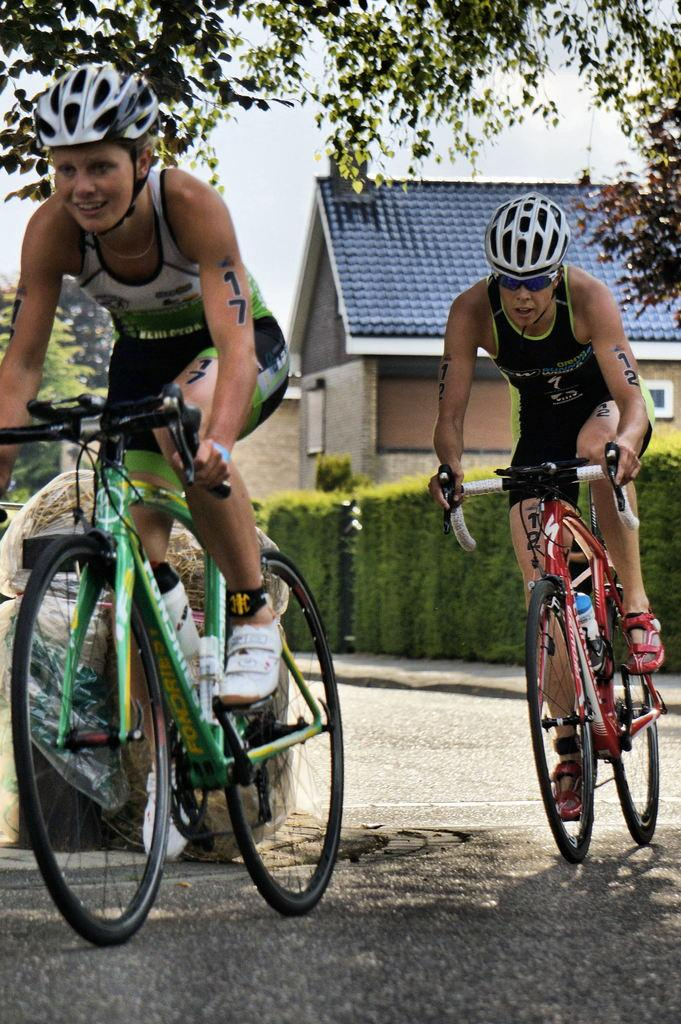What are the two people in the image doing? The two people in the image are riding bicycles. Where are the bicycles located? The bicycles are on a road. What can be seen in the background of the image? In the background of the image, there are shrubs, wooden houses, trees, and the sky. What type of button is being used to control the bicycles in the image? There is no button present in the image; the bicycles are being ridden by the two people. What nation are the people riding bicycles in the image from? The image does not provide any information about the nationality of the people riding bicycles. 